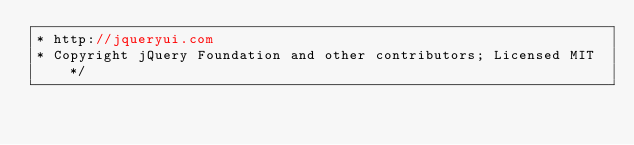<code> <loc_0><loc_0><loc_500><loc_500><_JavaScript_>* http://jqueryui.com
* Copyright jQuery Foundation and other contributors; Licensed MIT */</code> 